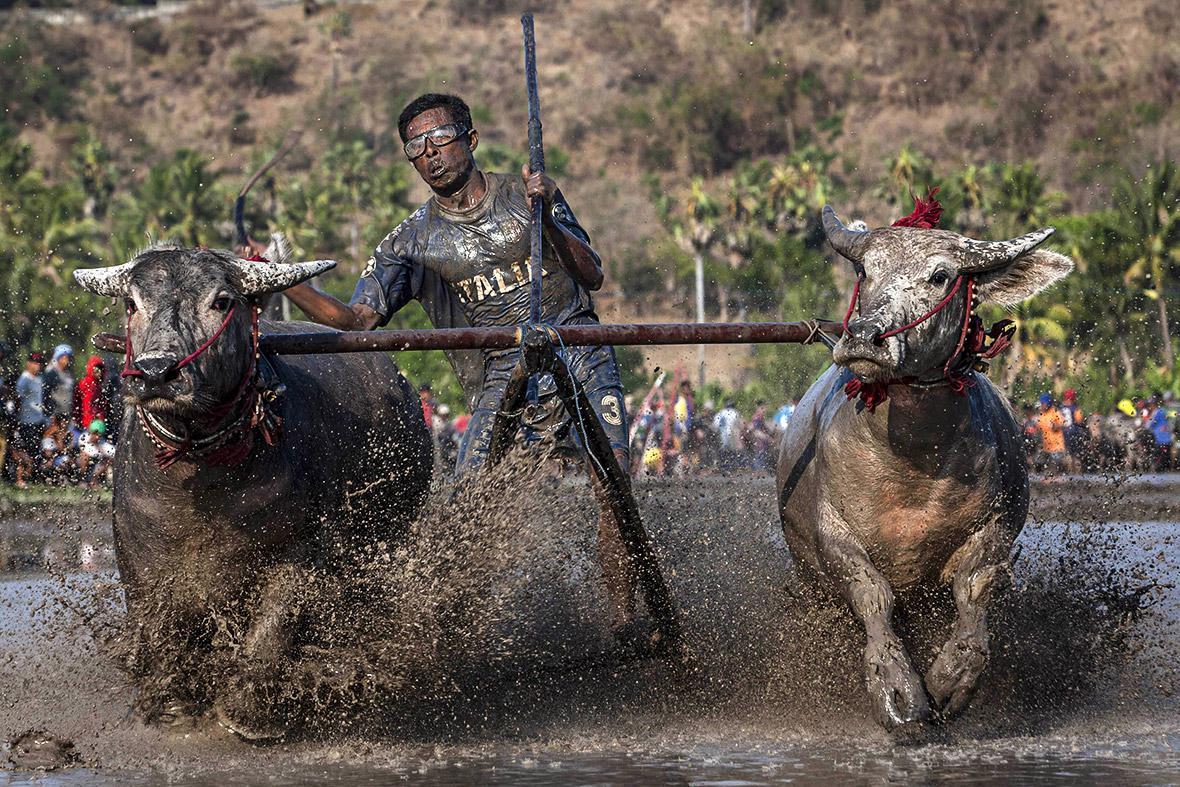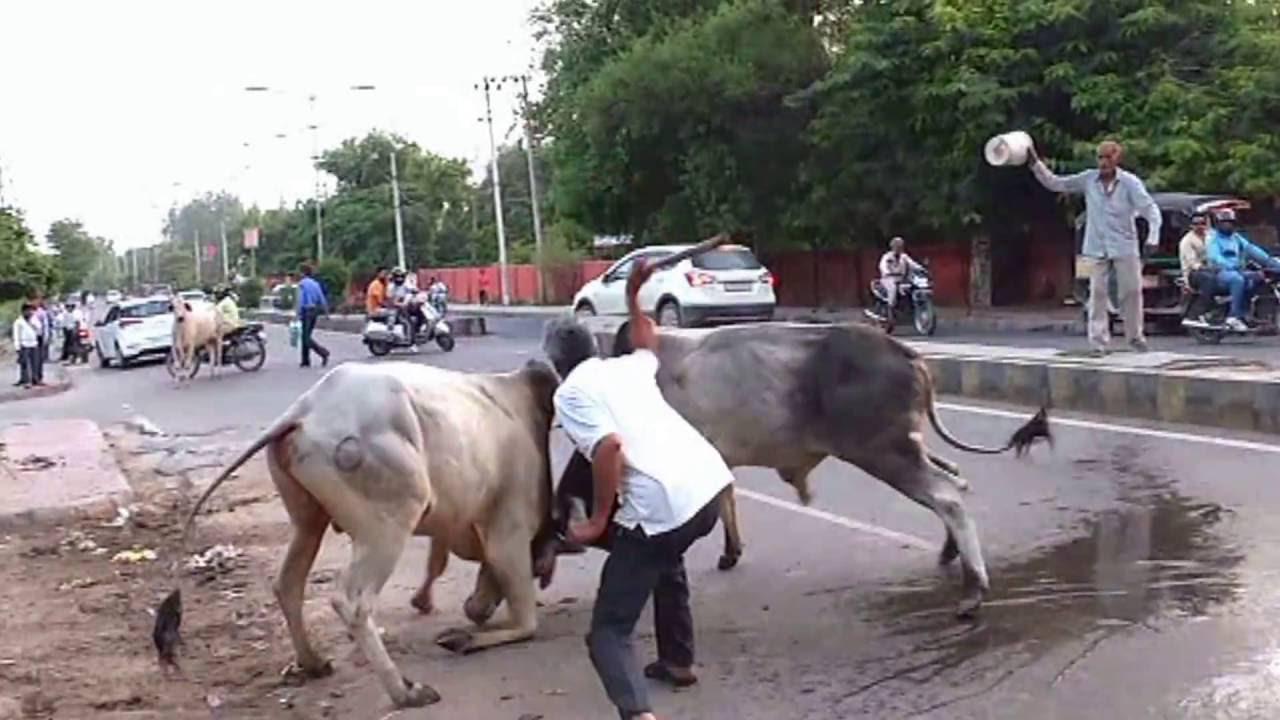The first image is the image on the left, the second image is the image on the right. Evaluate the accuracy of this statement regarding the images: "In the left image, a man in a colored head wrap is standing behind two dark oxen and holding out a stick.". Is it true? Answer yes or no. No. The first image is the image on the left, the second image is the image on the right. Examine the images to the left and right. Is the description "A man is hitting an animal with a stick." accurate? Answer yes or no. Yes. 